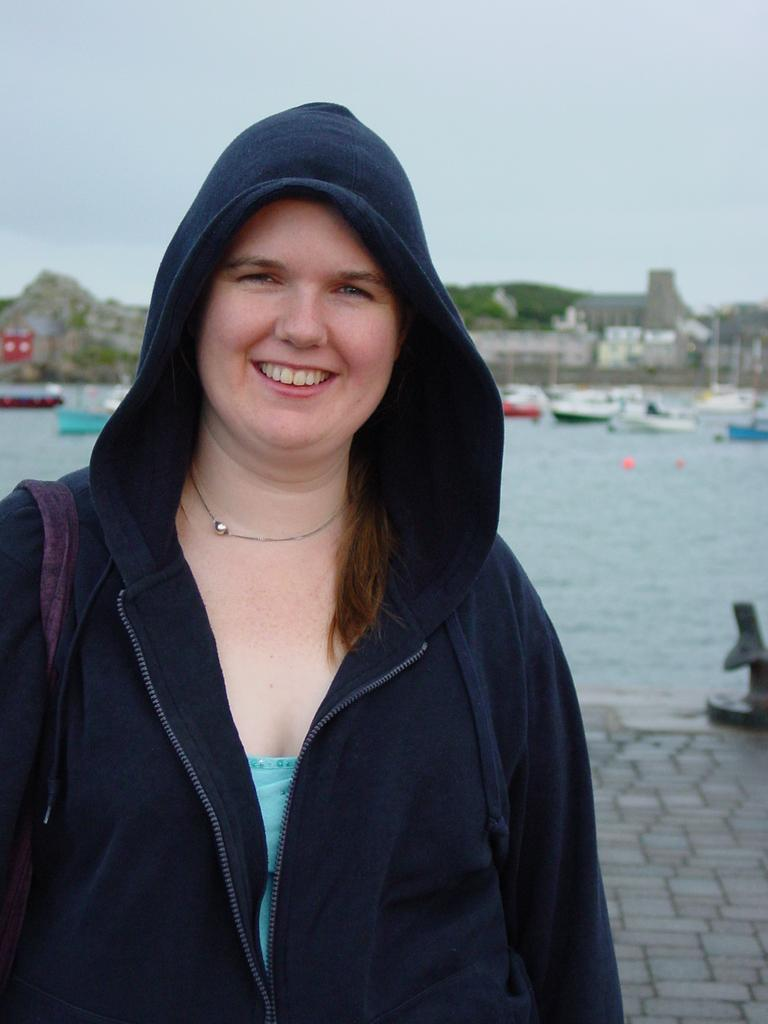What can be seen in the image? There is a person in the image. What is the person wearing? The person is wearing a navy blue jacket and a bag. What can be seen in the background of the image? There are boats, water, trees, and the sky in the background. What is the color of the sky in the image? The sky is blue and white in color. What type of engine is being advertised in the image? There is no engine or advertisement present in the image. Can you tell me how the person's clothing will change throughout the day? The image only shows the person's clothing at a specific moment, so we cannot predict how it might change throughout the day. 